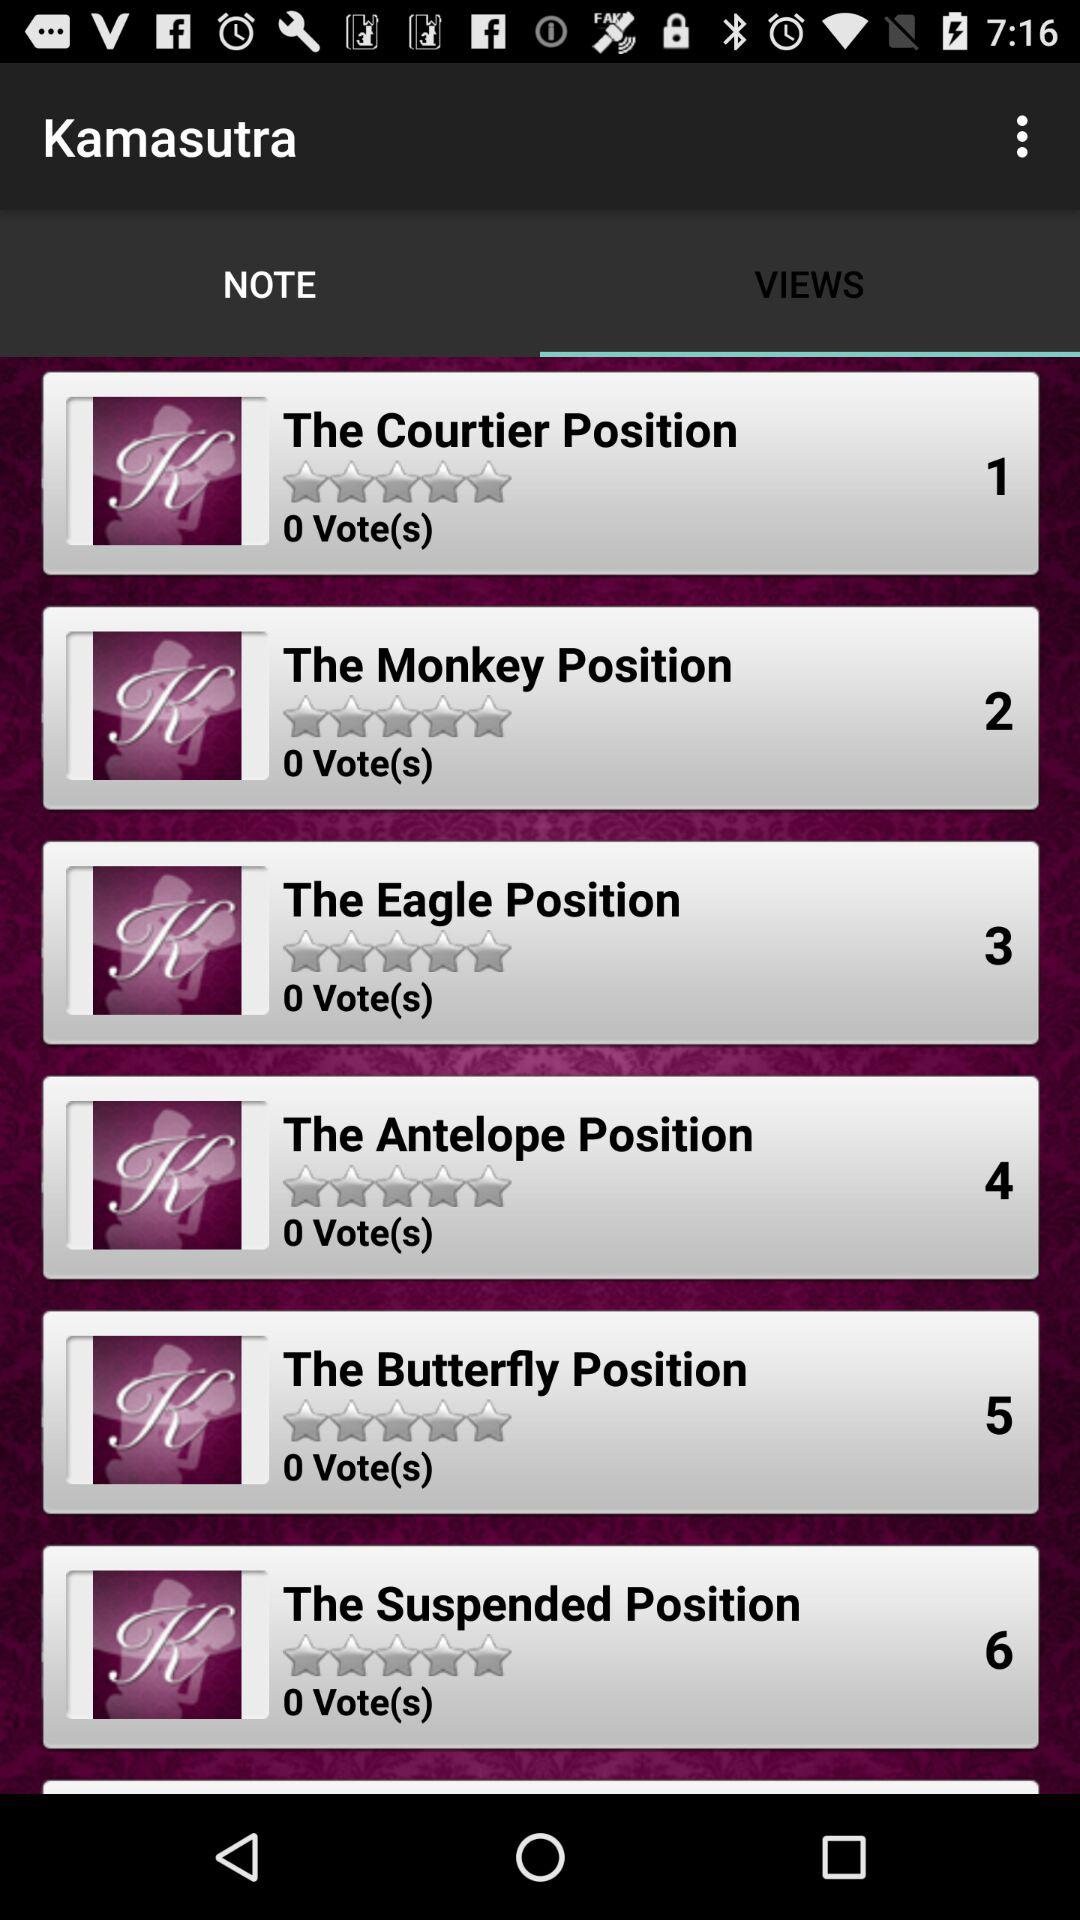What are the different note in Kamasutra?
When the provided information is insufficient, respond with <no answer>. <no answer> 